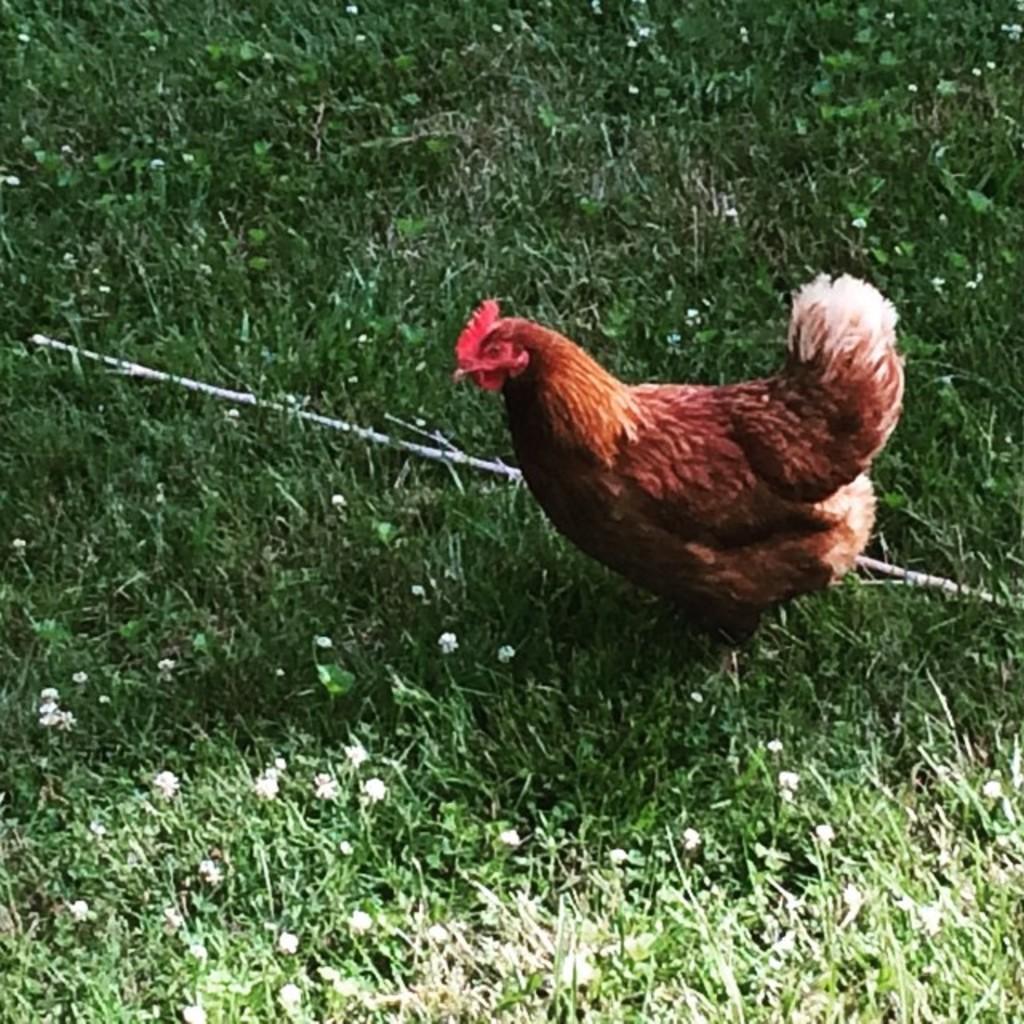Please provide a concise description of this image. In this given picture, We can see a garden, a tiny white color flowers after that, We can see a hen standing next, We can see a stick, few leaves. 